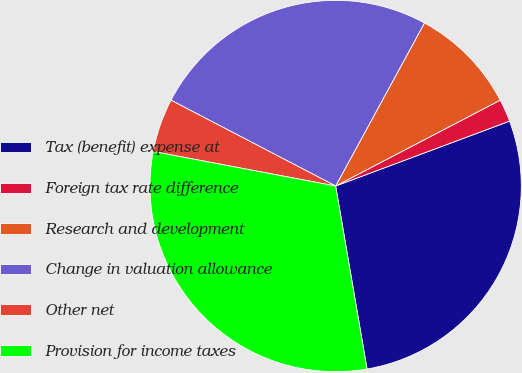Convert chart. <chart><loc_0><loc_0><loc_500><loc_500><pie_chart><fcel>Tax (benefit) expense at<fcel>Foreign tax rate difference<fcel>Research and development<fcel>Change in valuation allowance<fcel>Other net<fcel>Provision for income taxes<nl><fcel>27.98%<fcel>1.97%<fcel>9.41%<fcel>25.29%<fcel>4.67%<fcel>30.68%<nl></chart> 